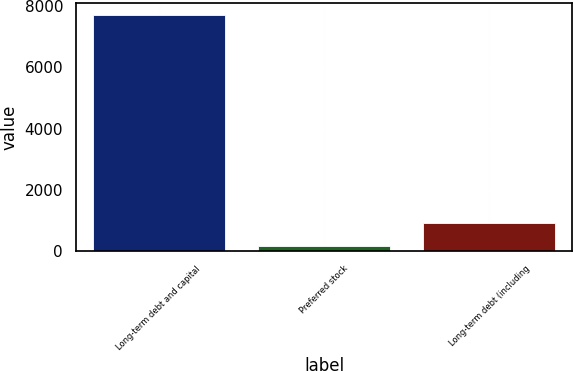Convert chart. <chart><loc_0><loc_0><loc_500><loc_500><bar_chart><fcel>Long-term debt and capital<fcel>Preferred stock<fcel>Long-term debt (including<nl><fcel>7719<fcel>150<fcel>906.9<nl></chart> 